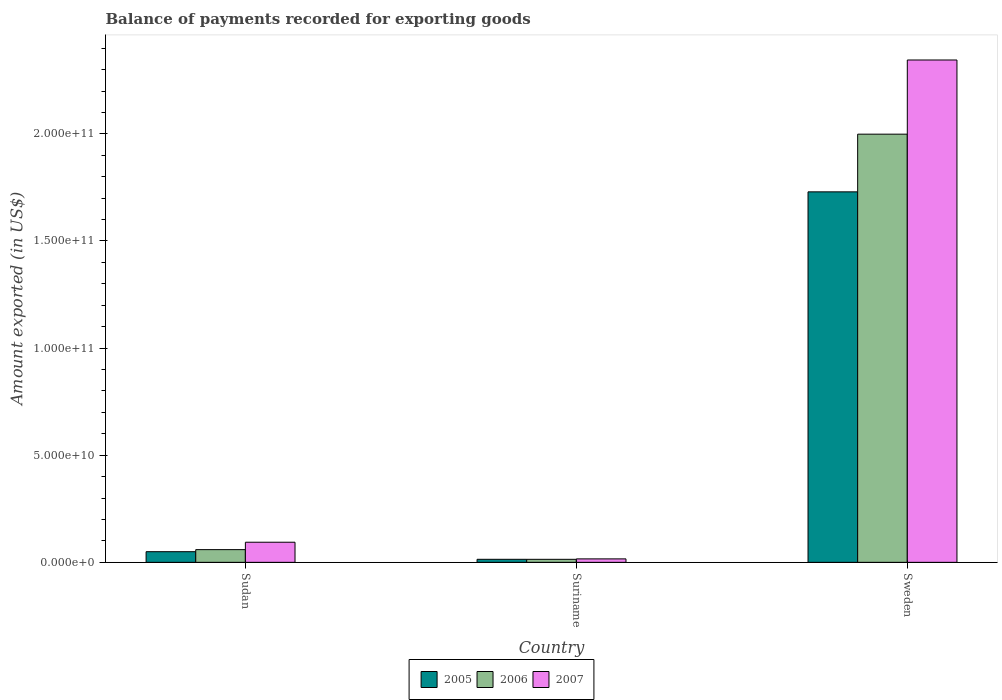How many groups of bars are there?
Make the answer very short. 3. Are the number of bars on each tick of the X-axis equal?
Your answer should be compact. Yes. How many bars are there on the 1st tick from the left?
Keep it short and to the point. 3. How many bars are there on the 1st tick from the right?
Provide a short and direct response. 3. What is the label of the 1st group of bars from the left?
Provide a succinct answer. Sudan. What is the amount exported in 2005 in Sweden?
Your response must be concise. 1.73e+11. Across all countries, what is the maximum amount exported in 2007?
Offer a terse response. 2.34e+11. Across all countries, what is the minimum amount exported in 2007?
Provide a succinct answer. 1.61e+09. In which country was the amount exported in 2005 maximum?
Offer a terse response. Sweden. In which country was the amount exported in 2006 minimum?
Offer a terse response. Suriname. What is the total amount exported in 2006 in the graph?
Ensure brevity in your answer.  2.07e+11. What is the difference between the amount exported in 2007 in Sudan and that in Suriname?
Your answer should be compact. 7.78e+09. What is the difference between the amount exported in 2005 in Suriname and the amount exported in 2006 in Sudan?
Make the answer very short. -4.51e+09. What is the average amount exported in 2006 per country?
Your answer should be compact. 6.91e+1. What is the difference between the amount exported of/in 2007 and amount exported of/in 2005 in Suriname?
Offer a terse response. 1.97e+08. In how many countries, is the amount exported in 2006 greater than 160000000000 US$?
Your answer should be very brief. 1. What is the ratio of the amount exported in 2006 in Sudan to that in Suriname?
Your response must be concise. 4.2. Is the amount exported in 2007 in Suriname less than that in Sweden?
Give a very brief answer. Yes. Is the difference between the amount exported in 2007 in Sudan and Sweden greater than the difference between the amount exported in 2005 in Sudan and Sweden?
Give a very brief answer. No. What is the difference between the highest and the second highest amount exported in 2005?
Provide a succinct answer. 1.68e+11. What is the difference between the highest and the lowest amount exported in 2007?
Provide a succinct answer. 2.33e+11. What does the 1st bar from the left in Suriname represents?
Your answer should be compact. 2005. What does the 2nd bar from the right in Suriname represents?
Provide a succinct answer. 2006. Are all the bars in the graph horizontal?
Give a very brief answer. No. Are the values on the major ticks of Y-axis written in scientific E-notation?
Offer a very short reply. Yes. Does the graph contain any zero values?
Make the answer very short. No. Where does the legend appear in the graph?
Keep it short and to the point. Bottom center. How are the legend labels stacked?
Ensure brevity in your answer.  Horizontal. What is the title of the graph?
Your answer should be very brief. Balance of payments recorded for exporting goods. What is the label or title of the X-axis?
Make the answer very short. Country. What is the label or title of the Y-axis?
Provide a succinct answer. Amount exported (in US$). What is the Amount exported (in US$) of 2005 in Sudan?
Your response must be concise. 4.97e+09. What is the Amount exported (in US$) in 2006 in Sudan?
Provide a short and direct response. 5.93e+09. What is the Amount exported (in US$) of 2007 in Sudan?
Your answer should be very brief. 9.39e+09. What is the Amount exported (in US$) in 2005 in Suriname?
Your answer should be very brief. 1.42e+09. What is the Amount exported (in US$) of 2006 in Suriname?
Your answer should be very brief. 1.41e+09. What is the Amount exported (in US$) in 2007 in Suriname?
Offer a terse response. 1.61e+09. What is the Amount exported (in US$) of 2005 in Sweden?
Ensure brevity in your answer.  1.73e+11. What is the Amount exported (in US$) of 2006 in Sweden?
Ensure brevity in your answer.  2.00e+11. What is the Amount exported (in US$) of 2007 in Sweden?
Offer a terse response. 2.34e+11. Across all countries, what is the maximum Amount exported (in US$) in 2005?
Keep it short and to the point. 1.73e+11. Across all countries, what is the maximum Amount exported (in US$) in 2006?
Ensure brevity in your answer.  2.00e+11. Across all countries, what is the maximum Amount exported (in US$) of 2007?
Your answer should be compact. 2.34e+11. Across all countries, what is the minimum Amount exported (in US$) in 2005?
Give a very brief answer. 1.42e+09. Across all countries, what is the minimum Amount exported (in US$) in 2006?
Make the answer very short. 1.41e+09. Across all countries, what is the minimum Amount exported (in US$) of 2007?
Provide a succinct answer. 1.61e+09. What is the total Amount exported (in US$) in 2005 in the graph?
Offer a terse response. 1.79e+11. What is the total Amount exported (in US$) of 2006 in the graph?
Give a very brief answer. 2.07e+11. What is the total Amount exported (in US$) of 2007 in the graph?
Your response must be concise. 2.45e+11. What is the difference between the Amount exported (in US$) of 2005 in Sudan and that in Suriname?
Keep it short and to the point. 3.56e+09. What is the difference between the Amount exported (in US$) in 2006 in Sudan and that in Suriname?
Your answer should be very brief. 4.52e+09. What is the difference between the Amount exported (in US$) of 2007 in Sudan and that in Suriname?
Offer a terse response. 7.78e+09. What is the difference between the Amount exported (in US$) of 2005 in Sudan and that in Sweden?
Provide a short and direct response. -1.68e+11. What is the difference between the Amount exported (in US$) in 2006 in Sudan and that in Sweden?
Keep it short and to the point. -1.94e+11. What is the difference between the Amount exported (in US$) in 2007 in Sudan and that in Sweden?
Give a very brief answer. -2.25e+11. What is the difference between the Amount exported (in US$) of 2005 in Suriname and that in Sweden?
Your answer should be compact. -1.72e+11. What is the difference between the Amount exported (in US$) of 2006 in Suriname and that in Sweden?
Make the answer very short. -1.98e+11. What is the difference between the Amount exported (in US$) of 2007 in Suriname and that in Sweden?
Offer a very short reply. -2.33e+11. What is the difference between the Amount exported (in US$) in 2005 in Sudan and the Amount exported (in US$) in 2006 in Suriname?
Your response must be concise. 3.56e+09. What is the difference between the Amount exported (in US$) in 2005 in Sudan and the Amount exported (in US$) in 2007 in Suriname?
Make the answer very short. 3.36e+09. What is the difference between the Amount exported (in US$) of 2006 in Sudan and the Amount exported (in US$) of 2007 in Suriname?
Offer a terse response. 4.32e+09. What is the difference between the Amount exported (in US$) in 2005 in Sudan and the Amount exported (in US$) in 2006 in Sweden?
Keep it short and to the point. -1.95e+11. What is the difference between the Amount exported (in US$) in 2005 in Sudan and the Amount exported (in US$) in 2007 in Sweden?
Provide a succinct answer. -2.30e+11. What is the difference between the Amount exported (in US$) in 2006 in Sudan and the Amount exported (in US$) in 2007 in Sweden?
Offer a terse response. -2.29e+11. What is the difference between the Amount exported (in US$) of 2005 in Suriname and the Amount exported (in US$) of 2006 in Sweden?
Provide a succinct answer. -1.98e+11. What is the difference between the Amount exported (in US$) in 2005 in Suriname and the Amount exported (in US$) in 2007 in Sweden?
Your answer should be compact. -2.33e+11. What is the difference between the Amount exported (in US$) of 2006 in Suriname and the Amount exported (in US$) of 2007 in Sweden?
Your answer should be very brief. -2.33e+11. What is the average Amount exported (in US$) in 2005 per country?
Make the answer very short. 5.98e+1. What is the average Amount exported (in US$) in 2006 per country?
Provide a succinct answer. 6.91e+1. What is the average Amount exported (in US$) of 2007 per country?
Your response must be concise. 8.18e+1. What is the difference between the Amount exported (in US$) of 2005 and Amount exported (in US$) of 2006 in Sudan?
Ensure brevity in your answer.  -9.59e+08. What is the difference between the Amount exported (in US$) in 2005 and Amount exported (in US$) in 2007 in Sudan?
Ensure brevity in your answer.  -4.42e+09. What is the difference between the Amount exported (in US$) in 2006 and Amount exported (in US$) in 2007 in Sudan?
Keep it short and to the point. -3.46e+09. What is the difference between the Amount exported (in US$) of 2005 and Amount exported (in US$) of 2006 in Suriname?
Ensure brevity in your answer.  4.50e+06. What is the difference between the Amount exported (in US$) in 2005 and Amount exported (in US$) in 2007 in Suriname?
Provide a succinct answer. -1.97e+08. What is the difference between the Amount exported (in US$) of 2006 and Amount exported (in US$) of 2007 in Suriname?
Your answer should be compact. -2.01e+08. What is the difference between the Amount exported (in US$) in 2005 and Amount exported (in US$) in 2006 in Sweden?
Offer a terse response. -2.69e+1. What is the difference between the Amount exported (in US$) in 2005 and Amount exported (in US$) in 2007 in Sweden?
Offer a very short reply. -6.15e+1. What is the difference between the Amount exported (in US$) of 2006 and Amount exported (in US$) of 2007 in Sweden?
Give a very brief answer. -3.46e+1. What is the ratio of the Amount exported (in US$) in 2005 in Sudan to that in Suriname?
Provide a short and direct response. 3.51. What is the ratio of the Amount exported (in US$) in 2006 in Sudan to that in Suriname?
Make the answer very short. 4.2. What is the ratio of the Amount exported (in US$) in 2007 in Sudan to that in Suriname?
Keep it short and to the point. 5.82. What is the ratio of the Amount exported (in US$) in 2005 in Sudan to that in Sweden?
Ensure brevity in your answer.  0.03. What is the ratio of the Amount exported (in US$) in 2006 in Sudan to that in Sweden?
Provide a succinct answer. 0.03. What is the ratio of the Amount exported (in US$) of 2005 in Suriname to that in Sweden?
Your answer should be compact. 0.01. What is the ratio of the Amount exported (in US$) in 2006 in Suriname to that in Sweden?
Provide a short and direct response. 0.01. What is the ratio of the Amount exported (in US$) in 2007 in Suriname to that in Sweden?
Your answer should be very brief. 0.01. What is the difference between the highest and the second highest Amount exported (in US$) of 2005?
Give a very brief answer. 1.68e+11. What is the difference between the highest and the second highest Amount exported (in US$) in 2006?
Keep it short and to the point. 1.94e+11. What is the difference between the highest and the second highest Amount exported (in US$) in 2007?
Offer a very short reply. 2.25e+11. What is the difference between the highest and the lowest Amount exported (in US$) of 2005?
Offer a very short reply. 1.72e+11. What is the difference between the highest and the lowest Amount exported (in US$) in 2006?
Provide a short and direct response. 1.98e+11. What is the difference between the highest and the lowest Amount exported (in US$) of 2007?
Make the answer very short. 2.33e+11. 